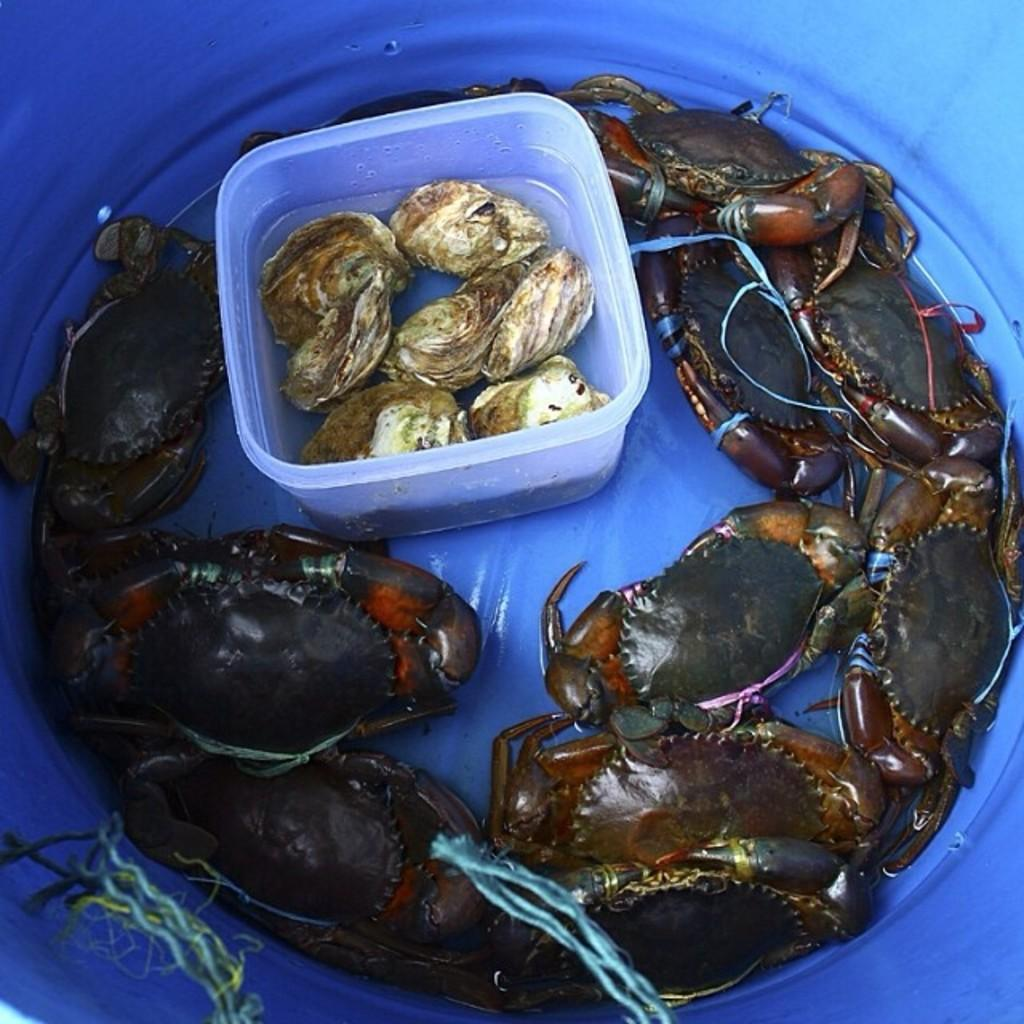What animals are in the tub in the image? There are crabs in a tub in the image. What animals are in the box in the image? There are ferrets in a box in the image. What is the box containing the ferrets filled with? The box contains water. How many girls are pushing the crabs in the tub in the image? There are no girls present in the image, and the crabs are not being pushed by anyone. 